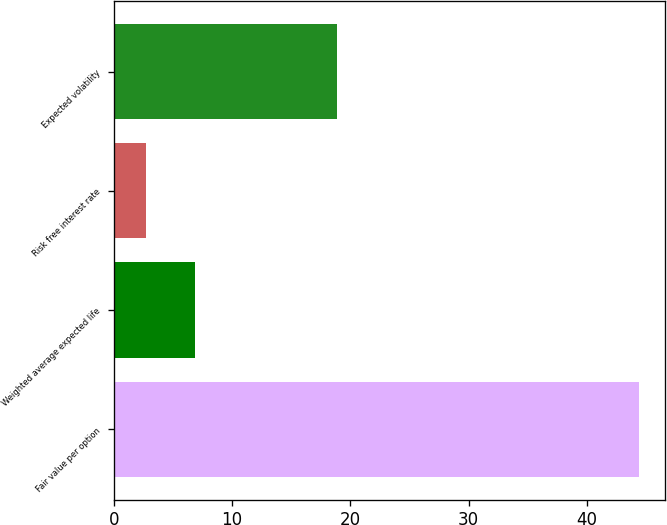Convert chart. <chart><loc_0><loc_0><loc_500><loc_500><bar_chart><fcel>Fair value per option<fcel>Weighted average expected life<fcel>Risk free interest rate<fcel>Expected volatility<nl><fcel>44.37<fcel>6.87<fcel>2.7<fcel>18.9<nl></chart> 